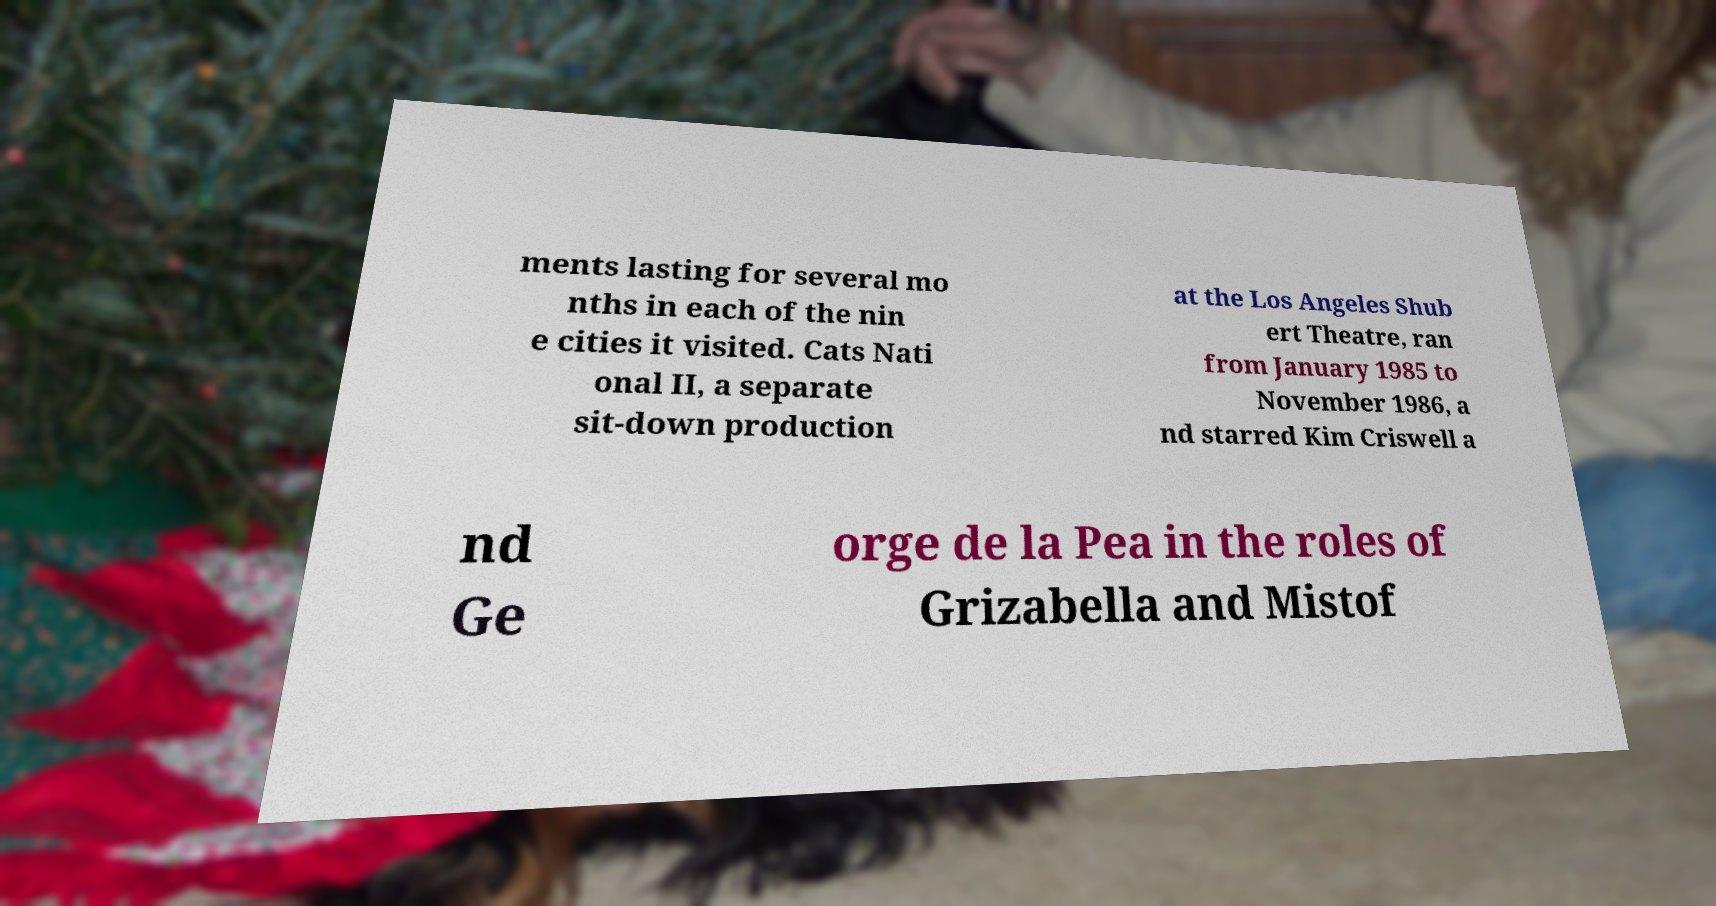Can you read and provide the text displayed in the image?This photo seems to have some interesting text. Can you extract and type it out for me? ments lasting for several mo nths in each of the nin e cities it visited. Cats Nati onal II, a separate sit-down production at the Los Angeles Shub ert Theatre, ran from January 1985 to November 1986, a nd starred Kim Criswell a nd Ge orge de la Pea in the roles of Grizabella and Mistof 